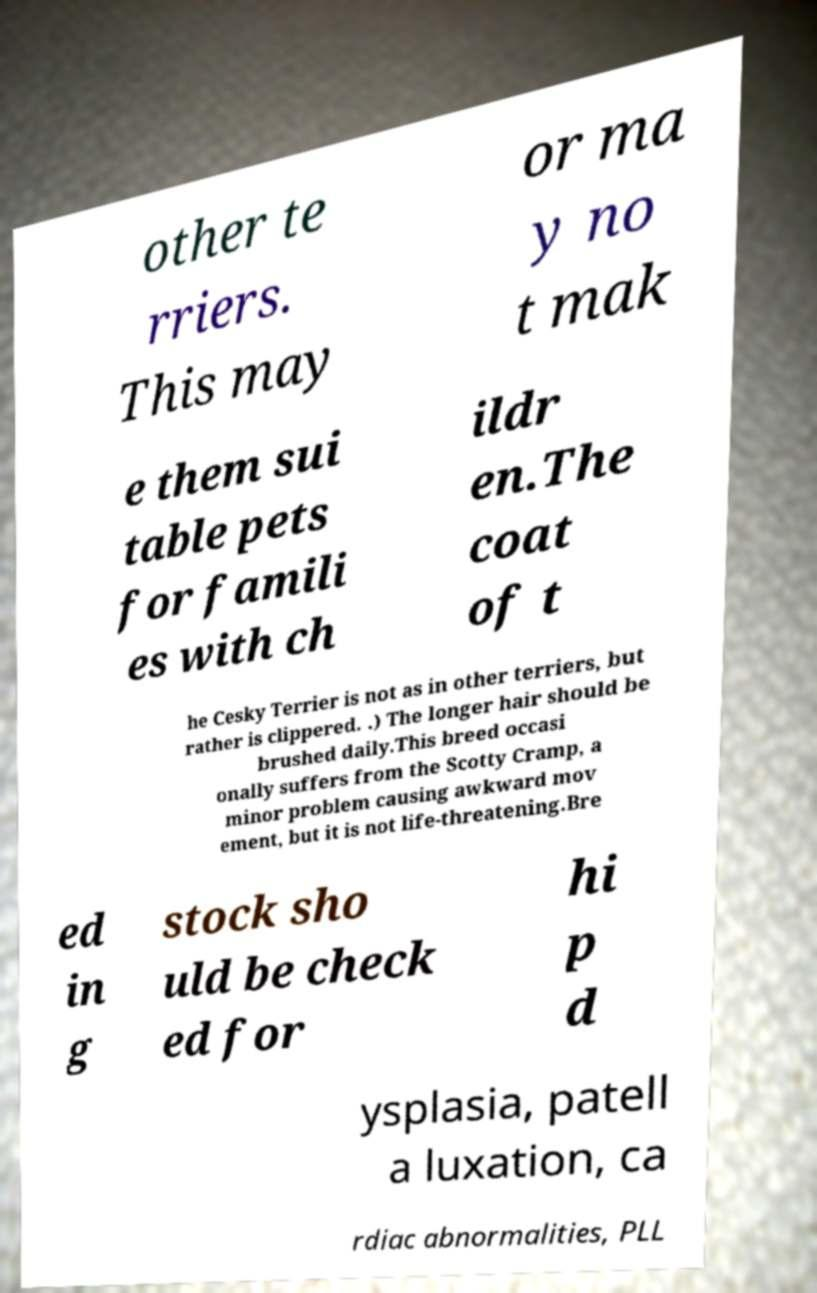Could you assist in decoding the text presented in this image and type it out clearly? other te rriers. This may or ma y no t mak e them sui table pets for famili es with ch ildr en.The coat of t he Cesky Terrier is not as in other terriers, but rather is clippered. .) The longer hair should be brushed daily.This breed occasi onally suffers from the Scotty Cramp, a minor problem causing awkward mov ement, but it is not life-threatening.Bre ed in g stock sho uld be check ed for hi p d ysplasia, patell a luxation, ca rdiac abnormalities, PLL 